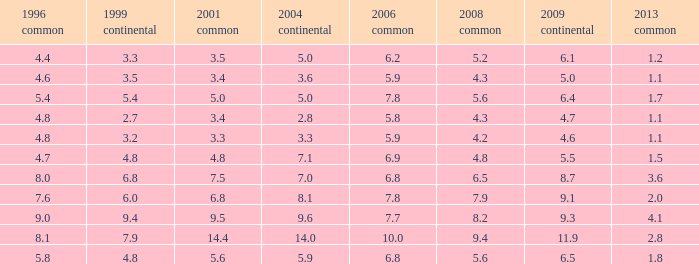How many values for 1999 European correspond to a value more than 4.7 in 2009 European, general 2001 more than 7.5, 2006 general at 10, and more than 9.4 in general 2008? 0.0. 